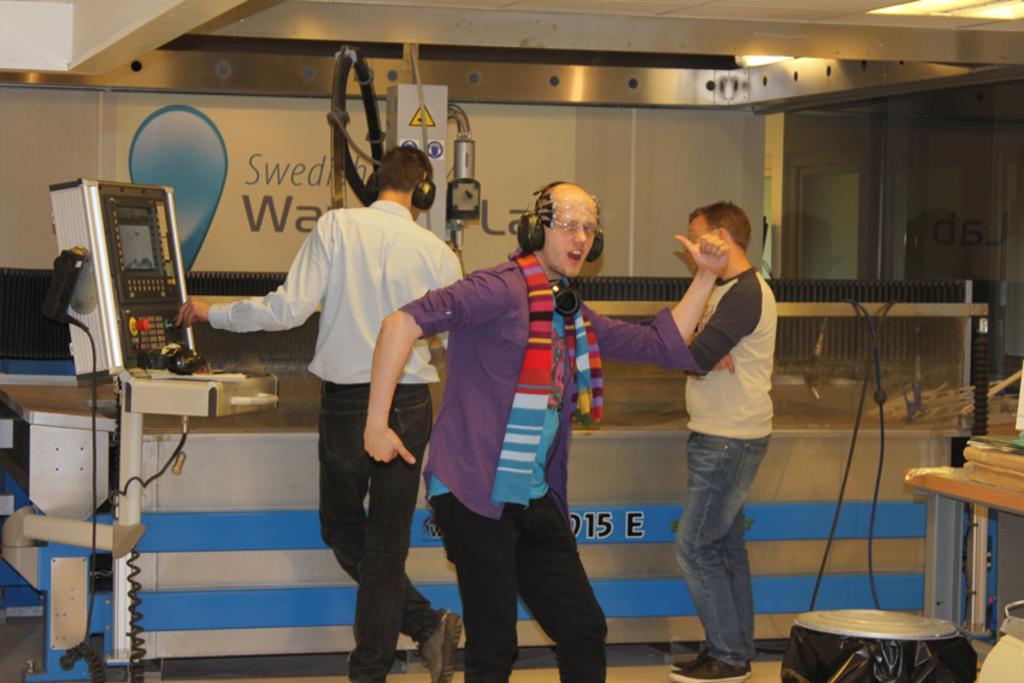In one or two sentences, can you explain what this image depicts? This person dancing and wired headset and these two people standing and this man wore headset. Right side of the image we can see object on the table. Here we can see electrical object with stand. In the background we can see electrical device,wall and banner. Top we can see lights. 